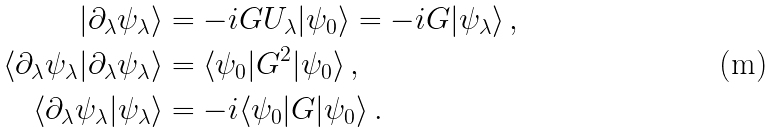<formula> <loc_0><loc_0><loc_500><loc_500>| \partial _ { \lambda } \psi _ { \lambda } \rangle & = - i G U _ { \lambda } | \psi _ { 0 } \rangle = - i G | \psi _ { \lambda } \rangle \, , \\ \langle \partial _ { \lambda } \psi _ { \lambda } | \partial _ { \lambda } \psi _ { \lambda } \rangle & = \langle \psi _ { 0 } | G ^ { 2 } | \psi _ { 0 } \rangle \, , \\ \langle \partial _ { \lambda } \psi _ { \lambda } | \psi _ { \lambda } \rangle & = - i \langle \psi _ { 0 } | G | \psi _ { 0 } \rangle \, .</formula> 